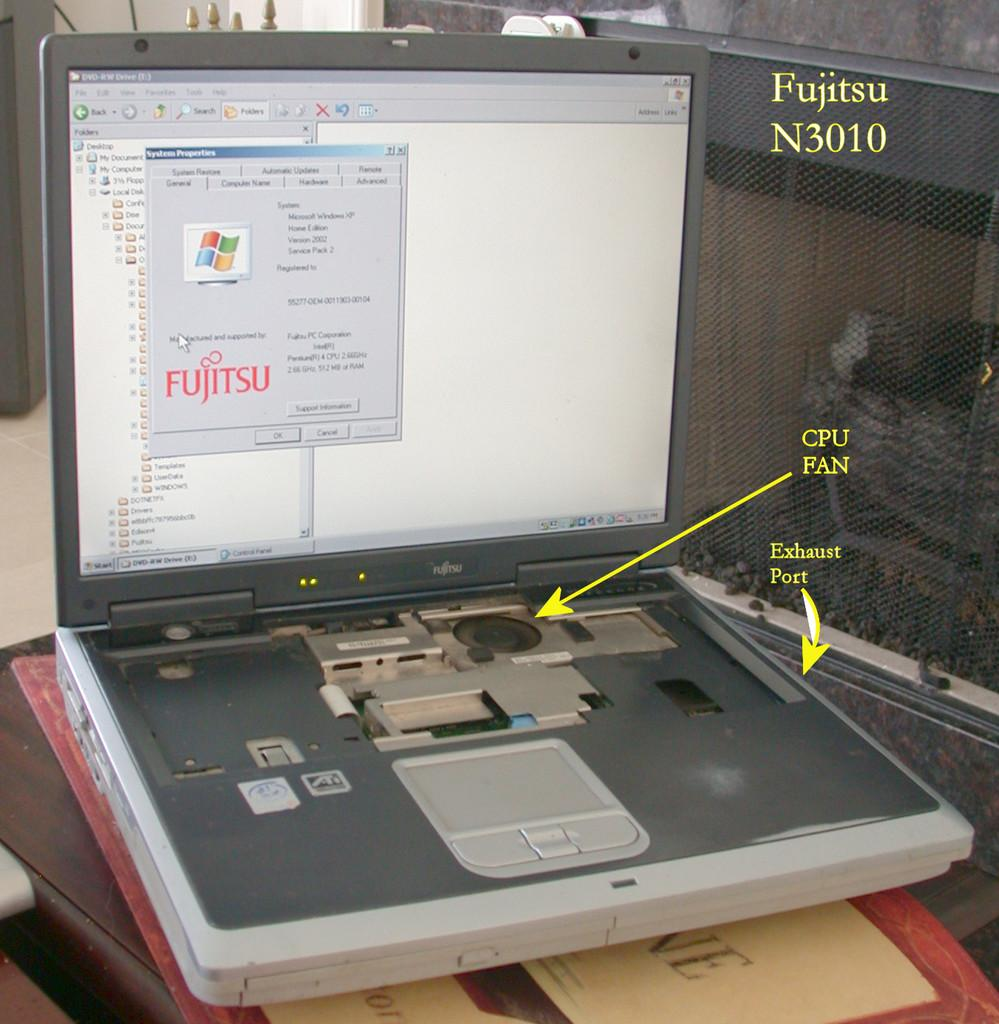Provide a one-sentence caption for the provided image. An old Fujitsu laptop has the CPU fan pointed out. 